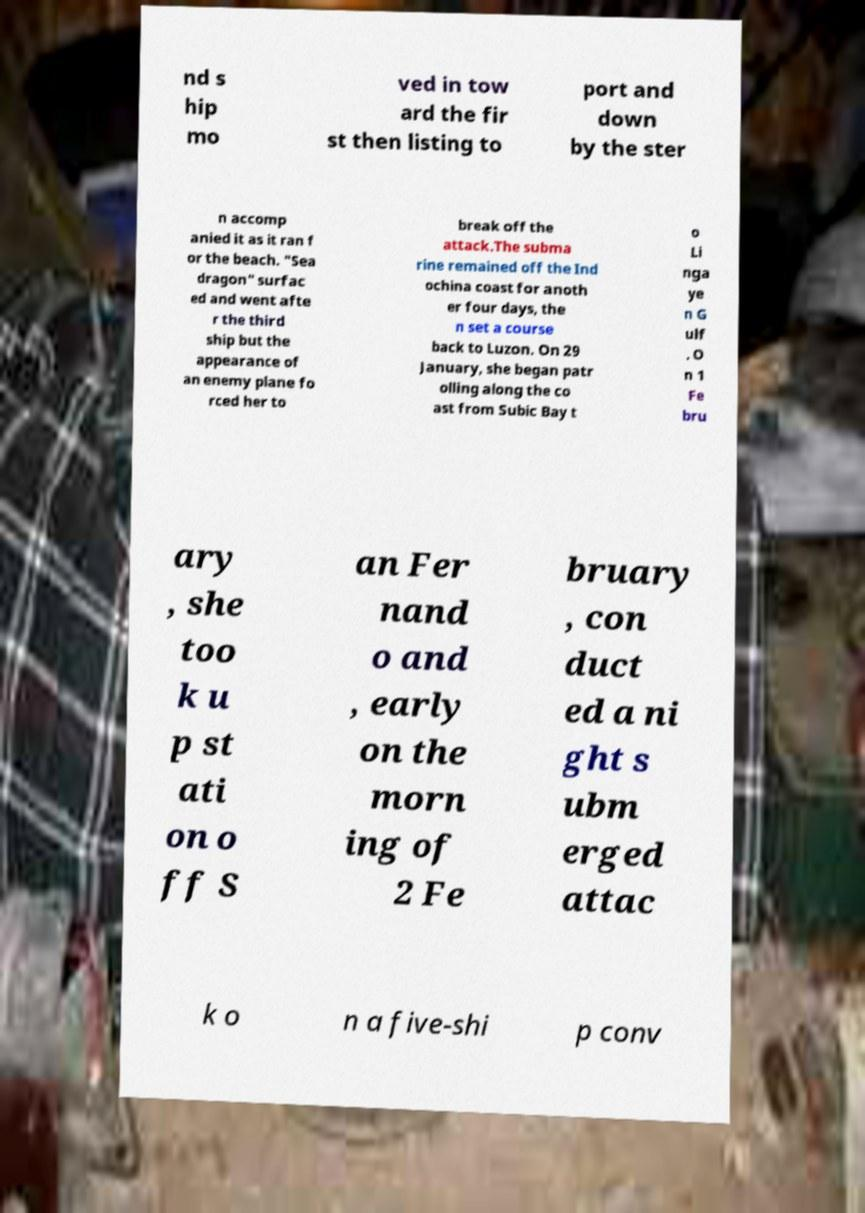Can you read and provide the text displayed in the image?This photo seems to have some interesting text. Can you extract and type it out for me? nd s hip mo ved in tow ard the fir st then listing to port and down by the ster n accomp anied it as it ran f or the beach. "Sea dragon" surfac ed and went afte r the third ship but the appearance of an enemy plane fo rced her to break off the attack.The subma rine remained off the Ind ochina coast for anoth er four days, the n set a course back to Luzon. On 29 January, she began patr olling along the co ast from Subic Bay t o Li nga ye n G ulf . O n 1 Fe bru ary , she too k u p st ati on o ff S an Fer nand o and , early on the morn ing of 2 Fe bruary , con duct ed a ni ght s ubm erged attac k o n a five-shi p conv 